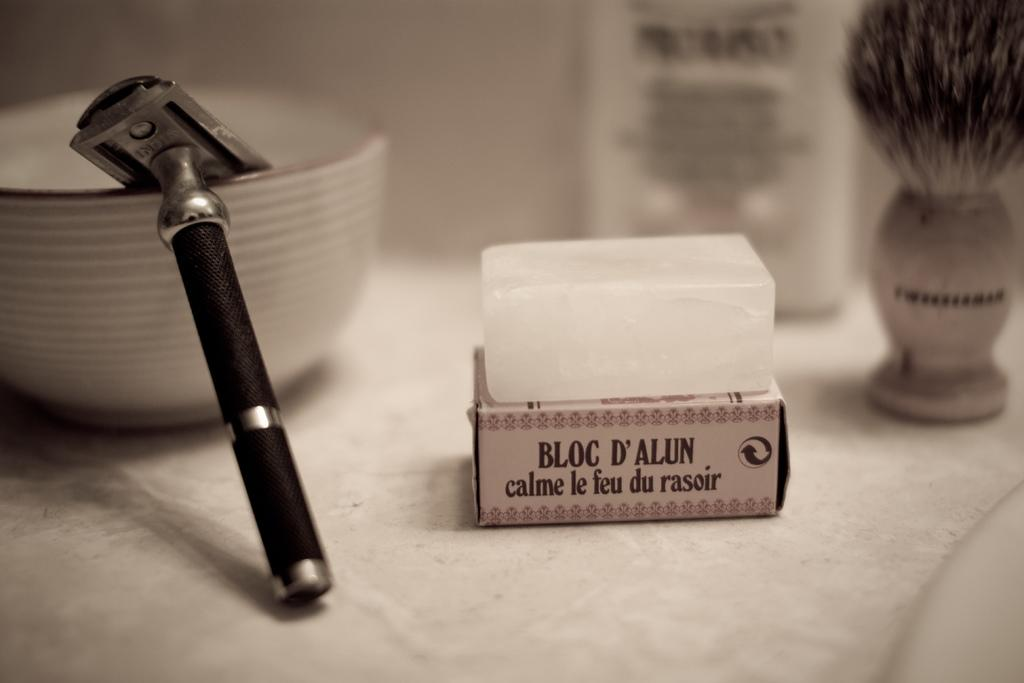<image>
Describe the image concisely. A bar of soap sits on a box by bloc d'alun. 